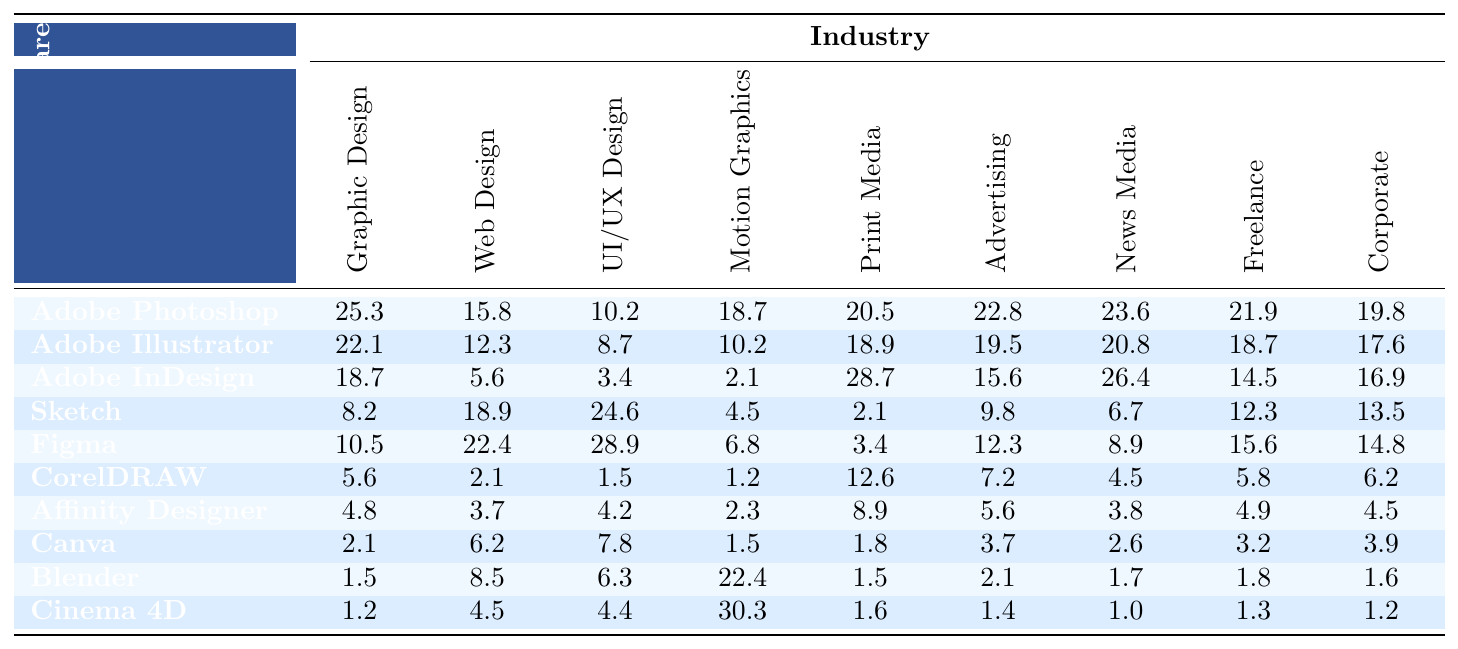What is the highest percentage of time spent on a single software by professionals in the Graphic Design industry? Adobe Photoshop has the highest percentage time of 25.3 in the Graphic Design industry, which can be referenced from the table.
Answer: 25.3 Which software has the lowest usage among UI/UX designers? According to the table, Affinity Designer has the lowest usage of 4.2 in the UI/UX Design category.
Answer: 4.2 What is the total percentage of time spent on Adobe products (Photoshop, Illustrator, InDesign) by Motion Graphics professionals? Summing the values of Adobe Photoshop (18.7), Adobe Illustrator (10.2), and Adobe InDesign (2.1) gives us 18.7 + 10.2 + 2.1 = 31.0.
Answer: 31.0 Is the time spent on Figma by UI/UX designers more than the combined time spent on Canva and Cinema 4D? Figma has a usage of 28.9 in UI/UX Design. Canva (7.8) and Cinema 4D (4.4) combined amount to 7.8 + 4.4 = 12.2. Since 28.9 is greater than 12.2, the statement is true.
Answer: Yes What software is most favored in Print Media, and how much time is spent using it? Adobe InDesign is favored in Print Media with a time spent of 28.7, which is the highest value in that category according to the table.
Answer: Adobe InDesign, 28.7 Calculate the average time spent by Freelancers using the software listed in the table. The total time spent by Freelancers is 21.9 + 18.7 + 14.5 + 12.3 + 15.6 + 5.8 + 4.9 + 3.2 + 1.8 + 1.3 = 99.0. Therefore, to calculate the average, we divide by the number of software (10): 99.0 / 10 = 9.9.
Answer: 9.9 Which industry has the highest overall software usage time for Sketch? Web Design has the highest usage time for Sketch, with 18.9%, as listed in the table.
Answer: Web Design, 18.9 Does the time spent on Blender in Motion Graphics exceed the combined time spent on Adobe Photoshop and Illustrator in the same field? Blender has 22.4 in Motion Graphics, while Adobe Photoshop and Illustrator total 18.7 + 10.2 = 28.9, which is not exceeded by Blender. Thus the statement is false.
Answer: No What percentage of the overall time spent on Advertising software tools correlates to Canva? Canva is allocated a percentage of 3.7 in Advertising. To find its correlation in relation to the total time spent across all Advertising tools, we look at the total which is 22.8 + 19.5 + 15.6 + 9.8 + 12.3 + 7.2 + 5.6 + 3.7 + 2.1 + 1.4 = 97.1. The percentage for Canva is (3.7 / 97.1) * 100 ≈ 3.8%.
Answer: Approximately 3.8% 